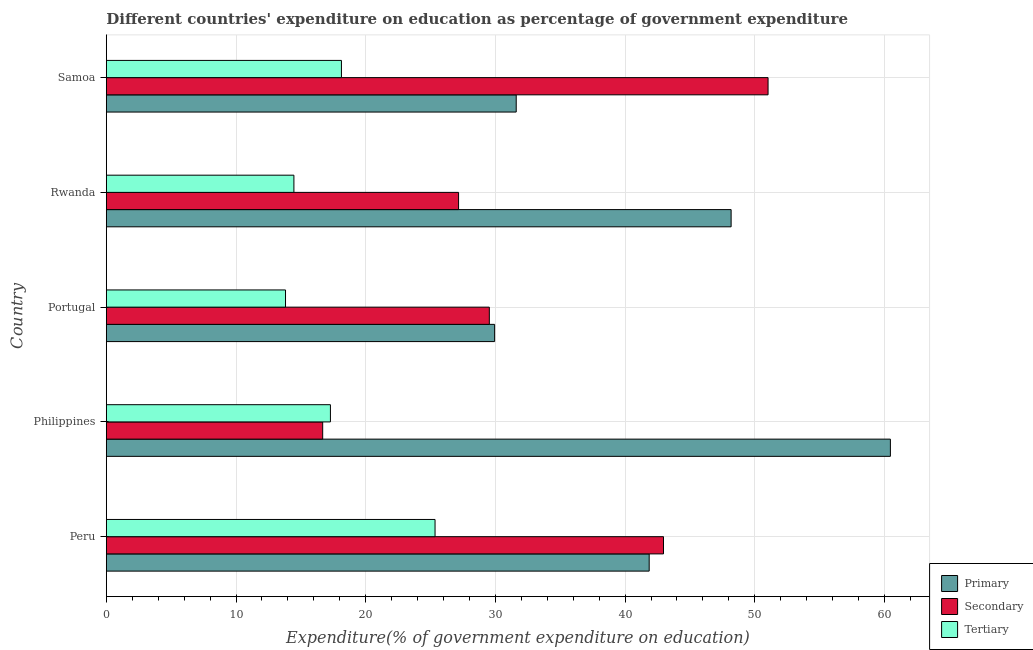Are the number of bars on each tick of the Y-axis equal?
Make the answer very short. Yes. How many bars are there on the 3rd tick from the top?
Offer a very short reply. 3. What is the label of the 2nd group of bars from the top?
Your answer should be very brief. Rwanda. What is the expenditure on tertiary education in Philippines?
Provide a short and direct response. 17.28. Across all countries, what is the maximum expenditure on primary education?
Your answer should be very brief. 60.46. Across all countries, what is the minimum expenditure on secondary education?
Your answer should be compact. 16.68. In which country was the expenditure on primary education maximum?
Offer a very short reply. Philippines. What is the total expenditure on tertiary education in the graph?
Offer a terse response. 89.04. What is the difference between the expenditure on secondary education in Philippines and that in Samoa?
Make the answer very short. -34.34. What is the difference between the expenditure on tertiary education in Peru and the expenditure on secondary education in Rwanda?
Your response must be concise. -1.82. What is the average expenditure on tertiary education per country?
Make the answer very short. 17.81. What is the difference between the expenditure on secondary education and expenditure on primary education in Portugal?
Keep it short and to the point. -0.41. In how many countries, is the expenditure on secondary education greater than 60 %?
Make the answer very short. 0. What is the ratio of the expenditure on secondary education in Peru to that in Samoa?
Your answer should be compact. 0.84. What is the difference between the highest and the second highest expenditure on tertiary education?
Your response must be concise. 7.22. What is the difference between the highest and the lowest expenditure on primary education?
Your answer should be compact. 30.52. What does the 2nd bar from the top in Rwanda represents?
Keep it short and to the point. Secondary. What does the 1st bar from the bottom in Peru represents?
Ensure brevity in your answer.  Primary. Are all the bars in the graph horizontal?
Make the answer very short. Yes. Does the graph contain any zero values?
Ensure brevity in your answer.  No. Does the graph contain grids?
Your answer should be very brief. Yes. Where does the legend appear in the graph?
Your answer should be compact. Bottom right. How many legend labels are there?
Make the answer very short. 3. How are the legend labels stacked?
Your answer should be very brief. Vertical. What is the title of the graph?
Offer a very short reply. Different countries' expenditure on education as percentage of government expenditure. What is the label or title of the X-axis?
Make the answer very short. Expenditure(% of government expenditure on education). What is the label or title of the Y-axis?
Keep it short and to the point. Country. What is the Expenditure(% of government expenditure on education) in Primary in Peru?
Make the answer very short. 41.86. What is the Expenditure(% of government expenditure on education) in Secondary in Peru?
Give a very brief answer. 42.96. What is the Expenditure(% of government expenditure on education) of Tertiary in Peru?
Make the answer very short. 25.35. What is the Expenditure(% of government expenditure on education) in Primary in Philippines?
Ensure brevity in your answer.  60.46. What is the Expenditure(% of government expenditure on education) in Secondary in Philippines?
Keep it short and to the point. 16.68. What is the Expenditure(% of government expenditure on education) in Tertiary in Philippines?
Make the answer very short. 17.28. What is the Expenditure(% of government expenditure on education) in Primary in Portugal?
Ensure brevity in your answer.  29.94. What is the Expenditure(% of government expenditure on education) in Secondary in Portugal?
Your answer should be very brief. 29.53. What is the Expenditure(% of government expenditure on education) in Tertiary in Portugal?
Give a very brief answer. 13.82. What is the Expenditure(% of government expenditure on education) in Primary in Rwanda?
Provide a short and direct response. 48.18. What is the Expenditure(% of government expenditure on education) in Secondary in Rwanda?
Your response must be concise. 27.16. What is the Expenditure(% of government expenditure on education) of Tertiary in Rwanda?
Your answer should be very brief. 14.46. What is the Expenditure(% of government expenditure on education) of Primary in Samoa?
Offer a very short reply. 31.61. What is the Expenditure(% of government expenditure on education) in Secondary in Samoa?
Your response must be concise. 51.03. What is the Expenditure(% of government expenditure on education) of Tertiary in Samoa?
Your response must be concise. 18.13. Across all countries, what is the maximum Expenditure(% of government expenditure on education) of Primary?
Give a very brief answer. 60.46. Across all countries, what is the maximum Expenditure(% of government expenditure on education) of Secondary?
Provide a short and direct response. 51.03. Across all countries, what is the maximum Expenditure(% of government expenditure on education) of Tertiary?
Keep it short and to the point. 25.35. Across all countries, what is the minimum Expenditure(% of government expenditure on education) in Primary?
Your answer should be compact. 29.94. Across all countries, what is the minimum Expenditure(% of government expenditure on education) of Secondary?
Your response must be concise. 16.68. Across all countries, what is the minimum Expenditure(% of government expenditure on education) in Tertiary?
Keep it short and to the point. 13.82. What is the total Expenditure(% of government expenditure on education) of Primary in the graph?
Give a very brief answer. 212.05. What is the total Expenditure(% of government expenditure on education) in Secondary in the graph?
Your response must be concise. 167.37. What is the total Expenditure(% of government expenditure on education) in Tertiary in the graph?
Provide a short and direct response. 89.04. What is the difference between the Expenditure(% of government expenditure on education) of Primary in Peru and that in Philippines?
Your answer should be very brief. -18.6. What is the difference between the Expenditure(% of government expenditure on education) in Secondary in Peru and that in Philippines?
Your answer should be compact. 26.28. What is the difference between the Expenditure(% of government expenditure on education) of Tertiary in Peru and that in Philippines?
Make the answer very short. 8.07. What is the difference between the Expenditure(% of government expenditure on education) in Primary in Peru and that in Portugal?
Your response must be concise. 11.92. What is the difference between the Expenditure(% of government expenditure on education) in Secondary in Peru and that in Portugal?
Offer a very short reply. 13.43. What is the difference between the Expenditure(% of government expenditure on education) of Tertiary in Peru and that in Portugal?
Offer a very short reply. 11.53. What is the difference between the Expenditure(% of government expenditure on education) in Primary in Peru and that in Rwanda?
Provide a short and direct response. -6.32. What is the difference between the Expenditure(% of government expenditure on education) in Secondary in Peru and that in Rwanda?
Ensure brevity in your answer.  15.8. What is the difference between the Expenditure(% of government expenditure on education) of Tertiary in Peru and that in Rwanda?
Your response must be concise. 10.88. What is the difference between the Expenditure(% of government expenditure on education) of Primary in Peru and that in Samoa?
Provide a short and direct response. 10.25. What is the difference between the Expenditure(% of government expenditure on education) of Secondary in Peru and that in Samoa?
Give a very brief answer. -8.06. What is the difference between the Expenditure(% of government expenditure on education) of Tertiary in Peru and that in Samoa?
Your response must be concise. 7.22. What is the difference between the Expenditure(% of government expenditure on education) in Primary in Philippines and that in Portugal?
Make the answer very short. 30.52. What is the difference between the Expenditure(% of government expenditure on education) in Secondary in Philippines and that in Portugal?
Your response must be concise. -12.85. What is the difference between the Expenditure(% of government expenditure on education) in Tertiary in Philippines and that in Portugal?
Offer a terse response. 3.46. What is the difference between the Expenditure(% of government expenditure on education) in Primary in Philippines and that in Rwanda?
Your answer should be compact. 12.28. What is the difference between the Expenditure(% of government expenditure on education) in Secondary in Philippines and that in Rwanda?
Offer a terse response. -10.48. What is the difference between the Expenditure(% of government expenditure on education) of Tertiary in Philippines and that in Rwanda?
Your response must be concise. 2.82. What is the difference between the Expenditure(% of government expenditure on education) in Primary in Philippines and that in Samoa?
Your answer should be very brief. 28.85. What is the difference between the Expenditure(% of government expenditure on education) in Secondary in Philippines and that in Samoa?
Provide a succinct answer. -34.34. What is the difference between the Expenditure(% of government expenditure on education) of Tertiary in Philippines and that in Samoa?
Give a very brief answer. -0.85. What is the difference between the Expenditure(% of government expenditure on education) of Primary in Portugal and that in Rwanda?
Your response must be concise. -18.24. What is the difference between the Expenditure(% of government expenditure on education) in Secondary in Portugal and that in Rwanda?
Ensure brevity in your answer.  2.37. What is the difference between the Expenditure(% of government expenditure on education) of Tertiary in Portugal and that in Rwanda?
Ensure brevity in your answer.  -0.65. What is the difference between the Expenditure(% of government expenditure on education) of Primary in Portugal and that in Samoa?
Make the answer very short. -1.66. What is the difference between the Expenditure(% of government expenditure on education) in Secondary in Portugal and that in Samoa?
Offer a very short reply. -21.49. What is the difference between the Expenditure(% of government expenditure on education) in Tertiary in Portugal and that in Samoa?
Your answer should be compact. -4.31. What is the difference between the Expenditure(% of government expenditure on education) of Primary in Rwanda and that in Samoa?
Keep it short and to the point. 16.57. What is the difference between the Expenditure(% of government expenditure on education) in Secondary in Rwanda and that in Samoa?
Give a very brief answer. -23.86. What is the difference between the Expenditure(% of government expenditure on education) in Tertiary in Rwanda and that in Samoa?
Provide a succinct answer. -3.67. What is the difference between the Expenditure(% of government expenditure on education) of Primary in Peru and the Expenditure(% of government expenditure on education) of Secondary in Philippines?
Offer a very short reply. 25.18. What is the difference between the Expenditure(% of government expenditure on education) in Primary in Peru and the Expenditure(% of government expenditure on education) in Tertiary in Philippines?
Keep it short and to the point. 24.58. What is the difference between the Expenditure(% of government expenditure on education) of Secondary in Peru and the Expenditure(% of government expenditure on education) of Tertiary in Philippines?
Ensure brevity in your answer.  25.68. What is the difference between the Expenditure(% of government expenditure on education) in Primary in Peru and the Expenditure(% of government expenditure on education) in Secondary in Portugal?
Your response must be concise. 12.33. What is the difference between the Expenditure(% of government expenditure on education) of Primary in Peru and the Expenditure(% of government expenditure on education) of Tertiary in Portugal?
Your response must be concise. 28.04. What is the difference between the Expenditure(% of government expenditure on education) of Secondary in Peru and the Expenditure(% of government expenditure on education) of Tertiary in Portugal?
Ensure brevity in your answer.  29.15. What is the difference between the Expenditure(% of government expenditure on education) in Primary in Peru and the Expenditure(% of government expenditure on education) in Secondary in Rwanda?
Keep it short and to the point. 14.7. What is the difference between the Expenditure(% of government expenditure on education) of Primary in Peru and the Expenditure(% of government expenditure on education) of Tertiary in Rwanda?
Your answer should be compact. 27.4. What is the difference between the Expenditure(% of government expenditure on education) of Secondary in Peru and the Expenditure(% of government expenditure on education) of Tertiary in Rwanda?
Keep it short and to the point. 28.5. What is the difference between the Expenditure(% of government expenditure on education) of Primary in Peru and the Expenditure(% of government expenditure on education) of Secondary in Samoa?
Provide a succinct answer. -9.17. What is the difference between the Expenditure(% of government expenditure on education) in Primary in Peru and the Expenditure(% of government expenditure on education) in Tertiary in Samoa?
Keep it short and to the point. 23.73. What is the difference between the Expenditure(% of government expenditure on education) in Secondary in Peru and the Expenditure(% of government expenditure on education) in Tertiary in Samoa?
Your answer should be compact. 24.83. What is the difference between the Expenditure(% of government expenditure on education) of Primary in Philippines and the Expenditure(% of government expenditure on education) of Secondary in Portugal?
Offer a terse response. 30.93. What is the difference between the Expenditure(% of government expenditure on education) of Primary in Philippines and the Expenditure(% of government expenditure on education) of Tertiary in Portugal?
Keep it short and to the point. 46.64. What is the difference between the Expenditure(% of government expenditure on education) of Secondary in Philippines and the Expenditure(% of government expenditure on education) of Tertiary in Portugal?
Ensure brevity in your answer.  2.87. What is the difference between the Expenditure(% of government expenditure on education) of Primary in Philippines and the Expenditure(% of government expenditure on education) of Secondary in Rwanda?
Your answer should be compact. 33.3. What is the difference between the Expenditure(% of government expenditure on education) of Primary in Philippines and the Expenditure(% of government expenditure on education) of Tertiary in Rwanda?
Offer a very short reply. 46. What is the difference between the Expenditure(% of government expenditure on education) of Secondary in Philippines and the Expenditure(% of government expenditure on education) of Tertiary in Rwanda?
Provide a succinct answer. 2.22. What is the difference between the Expenditure(% of government expenditure on education) of Primary in Philippines and the Expenditure(% of government expenditure on education) of Secondary in Samoa?
Your answer should be compact. 9.43. What is the difference between the Expenditure(% of government expenditure on education) of Primary in Philippines and the Expenditure(% of government expenditure on education) of Tertiary in Samoa?
Your answer should be very brief. 42.33. What is the difference between the Expenditure(% of government expenditure on education) in Secondary in Philippines and the Expenditure(% of government expenditure on education) in Tertiary in Samoa?
Your answer should be compact. -1.45. What is the difference between the Expenditure(% of government expenditure on education) in Primary in Portugal and the Expenditure(% of government expenditure on education) in Secondary in Rwanda?
Your response must be concise. 2.78. What is the difference between the Expenditure(% of government expenditure on education) in Primary in Portugal and the Expenditure(% of government expenditure on education) in Tertiary in Rwanda?
Your response must be concise. 15.48. What is the difference between the Expenditure(% of government expenditure on education) of Secondary in Portugal and the Expenditure(% of government expenditure on education) of Tertiary in Rwanda?
Your answer should be very brief. 15.07. What is the difference between the Expenditure(% of government expenditure on education) of Primary in Portugal and the Expenditure(% of government expenditure on education) of Secondary in Samoa?
Make the answer very short. -21.08. What is the difference between the Expenditure(% of government expenditure on education) of Primary in Portugal and the Expenditure(% of government expenditure on education) of Tertiary in Samoa?
Provide a short and direct response. 11.81. What is the difference between the Expenditure(% of government expenditure on education) in Secondary in Portugal and the Expenditure(% of government expenditure on education) in Tertiary in Samoa?
Give a very brief answer. 11.4. What is the difference between the Expenditure(% of government expenditure on education) of Primary in Rwanda and the Expenditure(% of government expenditure on education) of Secondary in Samoa?
Ensure brevity in your answer.  -2.85. What is the difference between the Expenditure(% of government expenditure on education) in Primary in Rwanda and the Expenditure(% of government expenditure on education) in Tertiary in Samoa?
Your response must be concise. 30.05. What is the difference between the Expenditure(% of government expenditure on education) of Secondary in Rwanda and the Expenditure(% of government expenditure on education) of Tertiary in Samoa?
Ensure brevity in your answer.  9.03. What is the average Expenditure(% of government expenditure on education) of Primary per country?
Provide a succinct answer. 42.41. What is the average Expenditure(% of government expenditure on education) in Secondary per country?
Your response must be concise. 33.47. What is the average Expenditure(% of government expenditure on education) of Tertiary per country?
Keep it short and to the point. 17.81. What is the difference between the Expenditure(% of government expenditure on education) of Primary and Expenditure(% of government expenditure on education) of Secondary in Peru?
Give a very brief answer. -1.1. What is the difference between the Expenditure(% of government expenditure on education) of Primary and Expenditure(% of government expenditure on education) of Tertiary in Peru?
Your answer should be very brief. 16.51. What is the difference between the Expenditure(% of government expenditure on education) of Secondary and Expenditure(% of government expenditure on education) of Tertiary in Peru?
Make the answer very short. 17.62. What is the difference between the Expenditure(% of government expenditure on education) of Primary and Expenditure(% of government expenditure on education) of Secondary in Philippines?
Make the answer very short. 43.78. What is the difference between the Expenditure(% of government expenditure on education) in Primary and Expenditure(% of government expenditure on education) in Tertiary in Philippines?
Your response must be concise. 43.18. What is the difference between the Expenditure(% of government expenditure on education) of Secondary and Expenditure(% of government expenditure on education) of Tertiary in Philippines?
Your answer should be compact. -0.6. What is the difference between the Expenditure(% of government expenditure on education) in Primary and Expenditure(% of government expenditure on education) in Secondary in Portugal?
Offer a terse response. 0.41. What is the difference between the Expenditure(% of government expenditure on education) of Primary and Expenditure(% of government expenditure on education) of Tertiary in Portugal?
Keep it short and to the point. 16.13. What is the difference between the Expenditure(% of government expenditure on education) of Secondary and Expenditure(% of government expenditure on education) of Tertiary in Portugal?
Your answer should be very brief. 15.72. What is the difference between the Expenditure(% of government expenditure on education) in Primary and Expenditure(% of government expenditure on education) in Secondary in Rwanda?
Keep it short and to the point. 21.02. What is the difference between the Expenditure(% of government expenditure on education) in Primary and Expenditure(% of government expenditure on education) in Tertiary in Rwanda?
Offer a terse response. 33.71. What is the difference between the Expenditure(% of government expenditure on education) in Secondary and Expenditure(% of government expenditure on education) in Tertiary in Rwanda?
Offer a very short reply. 12.7. What is the difference between the Expenditure(% of government expenditure on education) in Primary and Expenditure(% of government expenditure on education) in Secondary in Samoa?
Your response must be concise. -19.42. What is the difference between the Expenditure(% of government expenditure on education) in Primary and Expenditure(% of government expenditure on education) in Tertiary in Samoa?
Ensure brevity in your answer.  13.48. What is the difference between the Expenditure(% of government expenditure on education) in Secondary and Expenditure(% of government expenditure on education) in Tertiary in Samoa?
Give a very brief answer. 32.9. What is the ratio of the Expenditure(% of government expenditure on education) in Primary in Peru to that in Philippines?
Ensure brevity in your answer.  0.69. What is the ratio of the Expenditure(% of government expenditure on education) in Secondary in Peru to that in Philippines?
Keep it short and to the point. 2.58. What is the ratio of the Expenditure(% of government expenditure on education) of Tertiary in Peru to that in Philippines?
Provide a succinct answer. 1.47. What is the ratio of the Expenditure(% of government expenditure on education) of Primary in Peru to that in Portugal?
Your answer should be compact. 1.4. What is the ratio of the Expenditure(% of government expenditure on education) in Secondary in Peru to that in Portugal?
Keep it short and to the point. 1.45. What is the ratio of the Expenditure(% of government expenditure on education) of Tertiary in Peru to that in Portugal?
Your answer should be compact. 1.83. What is the ratio of the Expenditure(% of government expenditure on education) in Primary in Peru to that in Rwanda?
Make the answer very short. 0.87. What is the ratio of the Expenditure(% of government expenditure on education) of Secondary in Peru to that in Rwanda?
Keep it short and to the point. 1.58. What is the ratio of the Expenditure(% of government expenditure on education) in Tertiary in Peru to that in Rwanda?
Offer a very short reply. 1.75. What is the ratio of the Expenditure(% of government expenditure on education) of Primary in Peru to that in Samoa?
Provide a short and direct response. 1.32. What is the ratio of the Expenditure(% of government expenditure on education) in Secondary in Peru to that in Samoa?
Ensure brevity in your answer.  0.84. What is the ratio of the Expenditure(% of government expenditure on education) of Tertiary in Peru to that in Samoa?
Keep it short and to the point. 1.4. What is the ratio of the Expenditure(% of government expenditure on education) of Primary in Philippines to that in Portugal?
Your answer should be compact. 2.02. What is the ratio of the Expenditure(% of government expenditure on education) in Secondary in Philippines to that in Portugal?
Provide a succinct answer. 0.56. What is the ratio of the Expenditure(% of government expenditure on education) of Tertiary in Philippines to that in Portugal?
Ensure brevity in your answer.  1.25. What is the ratio of the Expenditure(% of government expenditure on education) of Primary in Philippines to that in Rwanda?
Provide a short and direct response. 1.25. What is the ratio of the Expenditure(% of government expenditure on education) in Secondary in Philippines to that in Rwanda?
Your answer should be compact. 0.61. What is the ratio of the Expenditure(% of government expenditure on education) of Tertiary in Philippines to that in Rwanda?
Provide a succinct answer. 1.19. What is the ratio of the Expenditure(% of government expenditure on education) of Primary in Philippines to that in Samoa?
Make the answer very short. 1.91. What is the ratio of the Expenditure(% of government expenditure on education) of Secondary in Philippines to that in Samoa?
Your answer should be compact. 0.33. What is the ratio of the Expenditure(% of government expenditure on education) in Tertiary in Philippines to that in Samoa?
Offer a terse response. 0.95. What is the ratio of the Expenditure(% of government expenditure on education) of Primary in Portugal to that in Rwanda?
Offer a terse response. 0.62. What is the ratio of the Expenditure(% of government expenditure on education) in Secondary in Portugal to that in Rwanda?
Your answer should be very brief. 1.09. What is the ratio of the Expenditure(% of government expenditure on education) in Tertiary in Portugal to that in Rwanda?
Your answer should be compact. 0.96. What is the ratio of the Expenditure(% of government expenditure on education) of Primary in Portugal to that in Samoa?
Offer a terse response. 0.95. What is the ratio of the Expenditure(% of government expenditure on education) in Secondary in Portugal to that in Samoa?
Provide a succinct answer. 0.58. What is the ratio of the Expenditure(% of government expenditure on education) in Tertiary in Portugal to that in Samoa?
Provide a short and direct response. 0.76. What is the ratio of the Expenditure(% of government expenditure on education) of Primary in Rwanda to that in Samoa?
Your response must be concise. 1.52. What is the ratio of the Expenditure(% of government expenditure on education) in Secondary in Rwanda to that in Samoa?
Offer a very short reply. 0.53. What is the ratio of the Expenditure(% of government expenditure on education) in Tertiary in Rwanda to that in Samoa?
Offer a very short reply. 0.8. What is the difference between the highest and the second highest Expenditure(% of government expenditure on education) of Primary?
Give a very brief answer. 12.28. What is the difference between the highest and the second highest Expenditure(% of government expenditure on education) in Secondary?
Your answer should be very brief. 8.06. What is the difference between the highest and the second highest Expenditure(% of government expenditure on education) in Tertiary?
Your response must be concise. 7.22. What is the difference between the highest and the lowest Expenditure(% of government expenditure on education) of Primary?
Keep it short and to the point. 30.52. What is the difference between the highest and the lowest Expenditure(% of government expenditure on education) of Secondary?
Make the answer very short. 34.34. What is the difference between the highest and the lowest Expenditure(% of government expenditure on education) of Tertiary?
Offer a terse response. 11.53. 